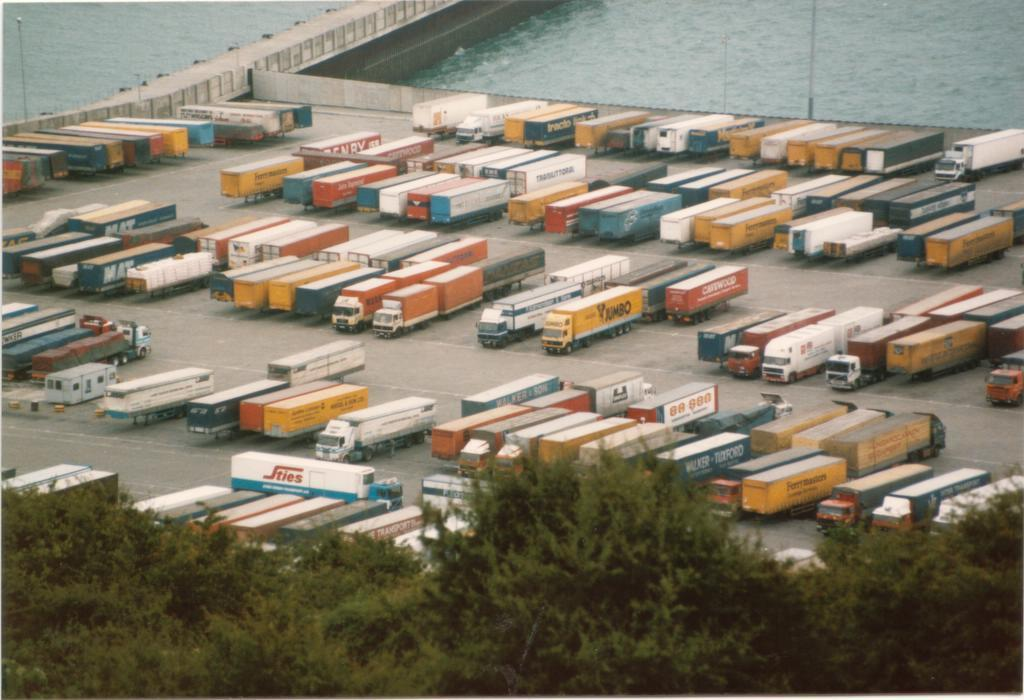What is the primary feature of the landscape in the image? There are many trees in the image. What else can be seen in the image besides trees? There are vehicles in the image. How would you describe the appearance of the vehicles? The vehicles are colorful. What can be seen in the background of the image? There are poles, a road, and water visible in the background of the image. How far away is the store from the trees in the image? There is no store present in the image, so it is not possible to determine the distance between the trees and a store. 